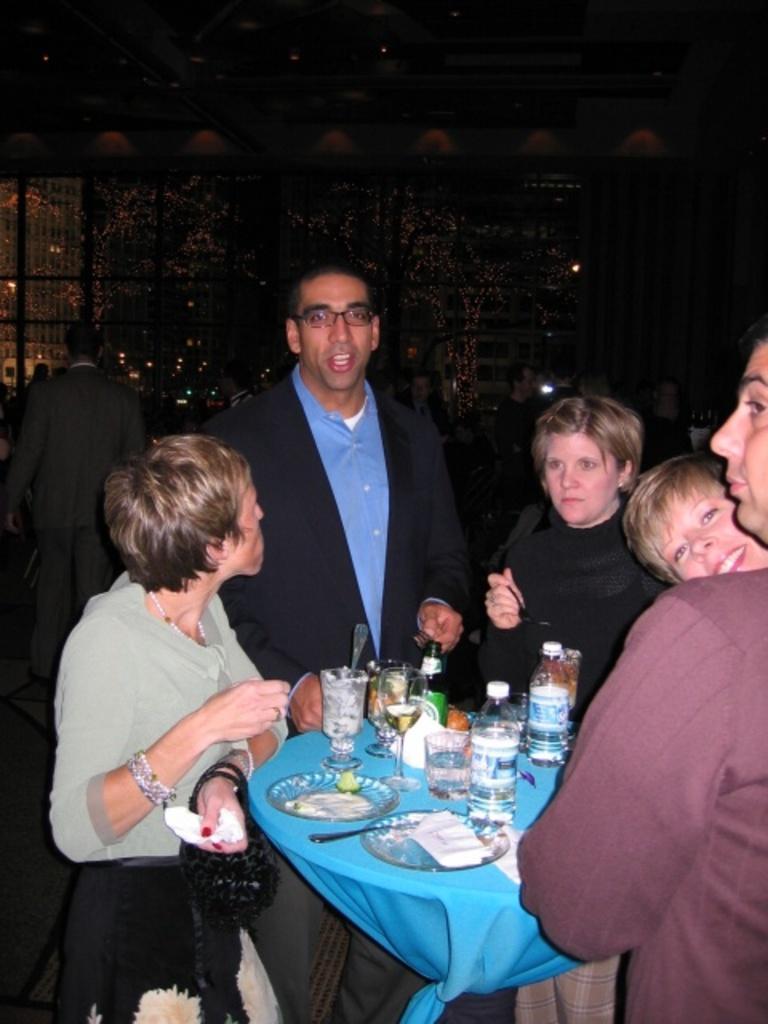Could you give a brief overview of what you see in this image? In this image there are group of people who are standing in front of a table. On table we can see a plate,tissues,spoon,glass,water bottle,fruit. On left side there is a man walking, in background we can see windows and doors and roof on top. 